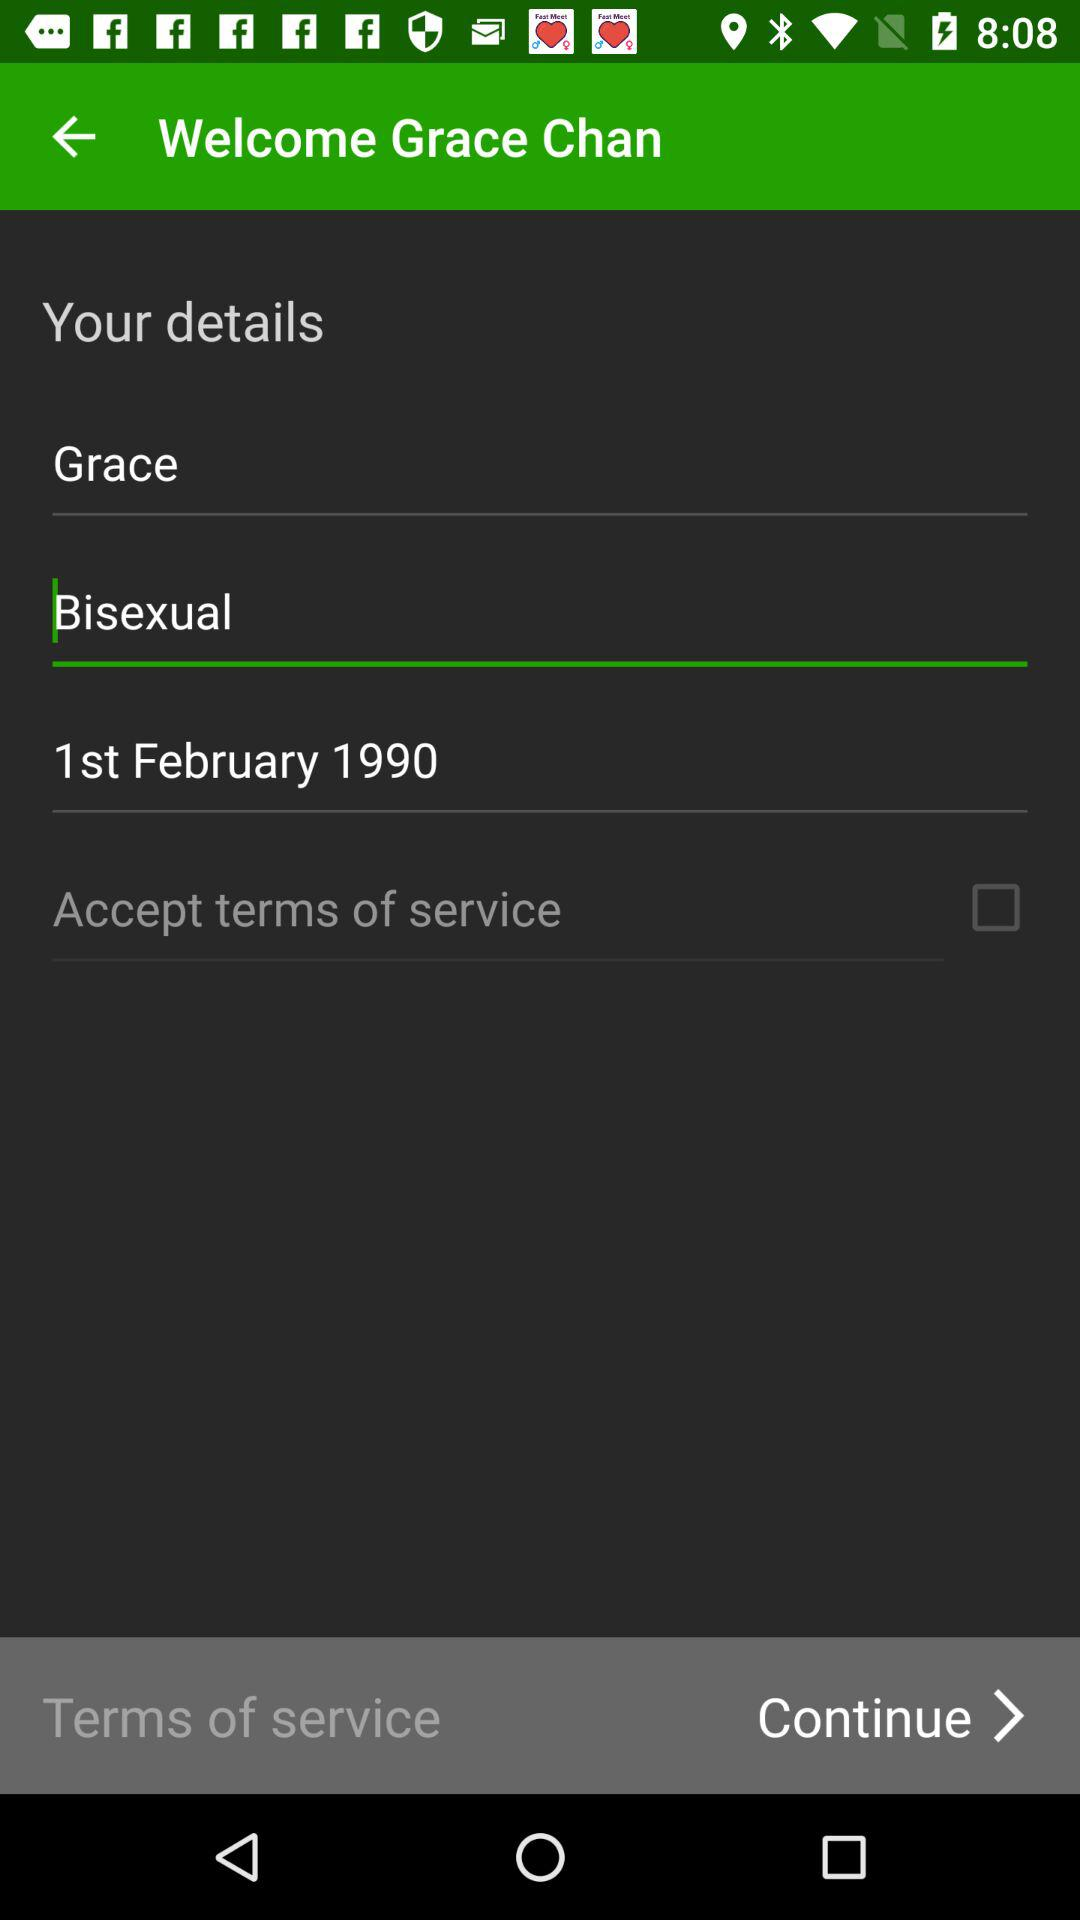What is the date of birth? The date of birth is February 1, 1990. 